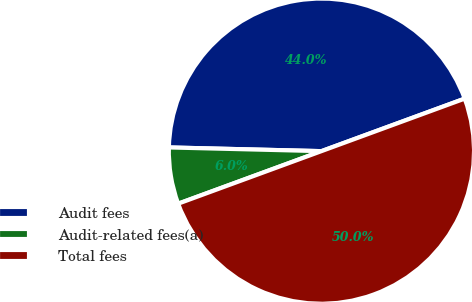<chart> <loc_0><loc_0><loc_500><loc_500><pie_chart><fcel>Audit fees<fcel>Audit-related fees(a)<fcel>Total fees<nl><fcel>44.02%<fcel>5.98%<fcel>50.0%<nl></chart> 